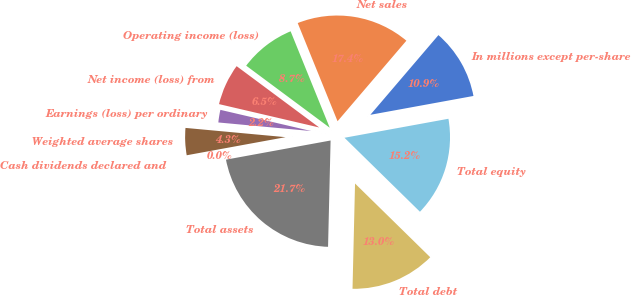Convert chart. <chart><loc_0><loc_0><loc_500><loc_500><pie_chart><fcel>In millions except per-share<fcel>Net sales<fcel>Operating income (loss)<fcel>Net income (loss) from<fcel>Earnings (loss) per ordinary<fcel>Weighted average shares<fcel>Cash dividends declared and<fcel>Total assets<fcel>Total debt<fcel>Total equity<nl><fcel>10.87%<fcel>17.39%<fcel>8.7%<fcel>6.52%<fcel>2.18%<fcel>4.35%<fcel>0.0%<fcel>21.74%<fcel>13.04%<fcel>15.22%<nl></chart> 